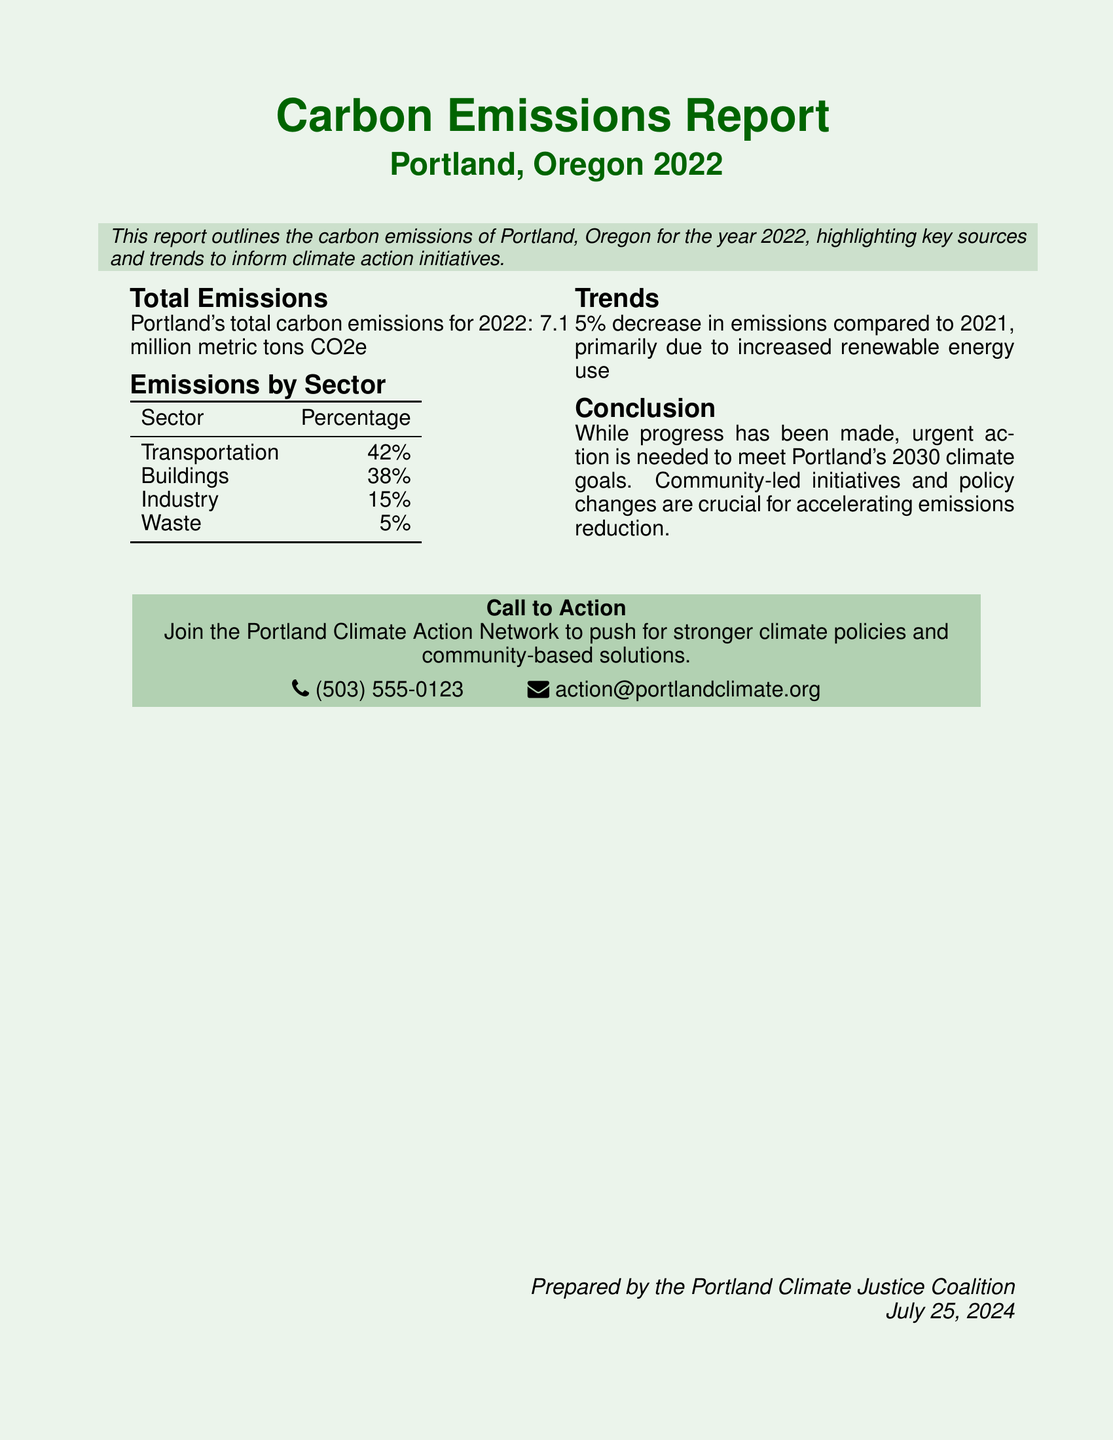What is the total carbon emissions for Portland in 2022? The total carbon emissions is stated clearly in the report as 7.1 million metric tons CO2e.
Answer: 7.1 million metric tons CO2e What is the percentage of emissions attributed to transportation? The document specifies that 42% of emissions come from the transportation sector.
Answer: 42% What sector has the lowest emissions percentage? The report details that the waste sector has the lowest emissions percentage at 5%.
Answer: 5% What was the trend in emissions from 2021 to 2022? The document mentions a 5% decrease in emissions compared to the previous year.
Answer: 5% decrease What is the primary reason for the decrease in emissions? The report notes that the decrease in emissions was primarily due to increased renewable energy use.
Answer: Increased renewable energy use What is the call to action in the report? The document encourages readers to join the Portland Climate Action Network for stronger climate policies and solutions.
Answer: Join the Portland Climate Action Network What is the purpose of the document? The report outlines Portland's carbon emissions to inform climate action initiatives.
Answer: Inform climate action initiatives Who prepared the report? The document credits the Portland Climate Justice Coalition as the preparer of the report.
Answer: Portland Climate Justice Coalition 